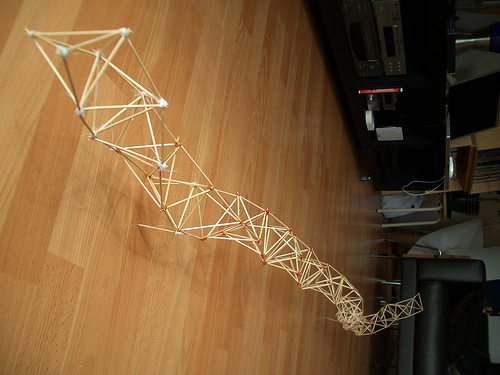<image>
Can you confirm if the matchsticks is above the sofa? No. The matchsticks is not positioned above the sofa. The vertical arrangement shows a different relationship. 